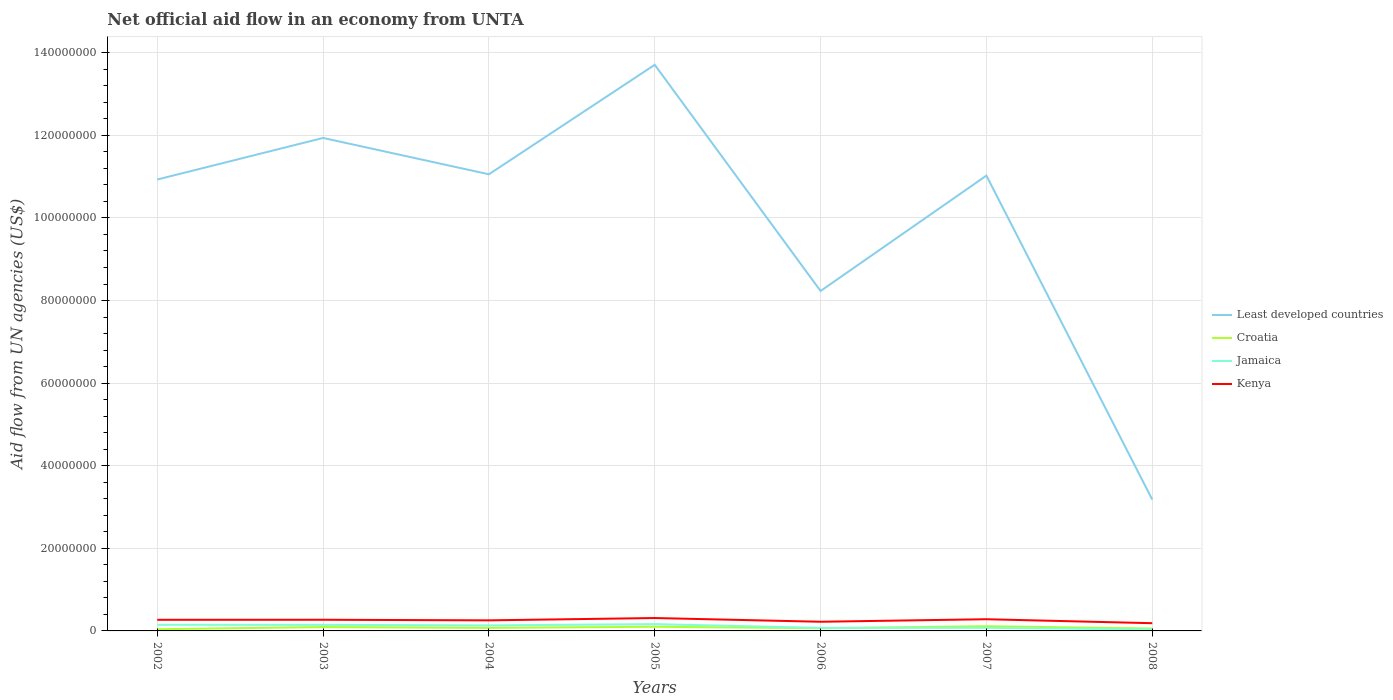How many different coloured lines are there?
Offer a very short reply. 4. Is the number of lines equal to the number of legend labels?
Your answer should be compact. Yes. Across all years, what is the maximum net official aid flow in Least developed countries?
Your response must be concise. 3.18e+07. What is the total net official aid flow in Croatia in the graph?
Ensure brevity in your answer.  4.40e+05. What is the difference between the highest and the second highest net official aid flow in Croatia?
Ensure brevity in your answer.  7.30e+05. Is the net official aid flow in Croatia strictly greater than the net official aid flow in Jamaica over the years?
Give a very brief answer. No. How many lines are there?
Provide a succinct answer. 4. Does the graph contain any zero values?
Offer a very short reply. No. Where does the legend appear in the graph?
Provide a short and direct response. Center right. How many legend labels are there?
Provide a succinct answer. 4. How are the legend labels stacked?
Your response must be concise. Vertical. What is the title of the graph?
Give a very brief answer. Net official aid flow in an economy from UNTA. Does "Tunisia" appear as one of the legend labels in the graph?
Give a very brief answer. No. What is the label or title of the X-axis?
Provide a succinct answer. Years. What is the label or title of the Y-axis?
Offer a very short reply. Aid flow from UN agencies (US$). What is the Aid flow from UN agencies (US$) of Least developed countries in 2002?
Offer a terse response. 1.09e+08. What is the Aid flow from UN agencies (US$) of Croatia in 2002?
Offer a very short reply. 4.10e+05. What is the Aid flow from UN agencies (US$) in Jamaica in 2002?
Your answer should be compact. 1.48e+06. What is the Aid flow from UN agencies (US$) of Kenya in 2002?
Offer a terse response. 2.69e+06. What is the Aid flow from UN agencies (US$) of Least developed countries in 2003?
Give a very brief answer. 1.19e+08. What is the Aid flow from UN agencies (US$) of Croatia in 2003?
Give a very brief answer. 9.30e+05. What is the Aid flow from UN agencies (US$) in Jamaica in 2003?
Provide a succinct answer. 1.47e+06. What is the Aid flow from UN agencies (US$) in Kenya in 2003?
Ensure brevity in your answer.  2.70e+06. What is the Aid flow from UN agencies (US$) of Least developed countries in 2004?
Your response must be concise. 1.11e+08. What is the Aid flow from UN agencies (US$) in Croatia in 2004?
Make the answer very short. 7.30e+05. What is the Aid flow from UN agencies (US$) in Jamaica in 2004?
Your answer should be compact. 1.34e+06. What is the Aid flow from UN agencies (US$) in Kenya in 2004?
Provide a short and direct response. 2.56e+06. What is the Aid flow from UN agencies (US$) in Least developed countries in 2005?
Provide a succinct answer. 1.37e+08. What is the Aid flow from UN agencies (US$) in Croatia in 2005?
Offer a very short reply. 1.01e+06. What is the Aid flow from UN agencies (US$) in Jamaica in 2005?
Provide a short and direct response. 1.65e+06. What is the Aid flow from UN agencies (US$) in Kenya in 2005?
Provide a short and direct response. 3.12e+06. What is the Aid flow from UN agencies (US$) of Least developed countries in 2006?
Provide a short and direct response. 8.23e+07. What is the Aid flow from UN agencies (US$) in Croatia in 2006?
Give a very brief answer. 6.50e+05. What is the Aid flow from UN agencies (US$) in Jamaica in 2006?
Offer a very short reply. 7.30e+05. What is the Aid flow from UN agencies (US$) in Kenya in 2006?
Offer a terse response. 2.22e+06. What is the Aid flow from UN agencies (US$) of Least developed countries in 2007?
Provide a short and direct response. 1.10e+08. What is the Aid flow from UN agencies (US$) of Croatia in 2007?
Offer a very short reply. 1.14e+06. What is the Aid flow from UN agencies (US$) of Jamaica in 2007?
Your answer should be compact. 7.40e+05. What is the Aid flow from UN agencies (US$) of Kenya in 2007?
Ensure brevity in your answer.  2.83e+06. What is the Aid flow from UN agencies (US$) of Least developed countries in 2008?
Your answer should be compact. 3.18e+07. What is the Aid flow from UN agencies (US$) in Croatia in 2008?
Make the answer very short. 5.70e+05. What is the Aid flow from UN agencies (US$) in Kenya in 2008?
Your answer should be very brief. 1.87e+06. Across all years, what is the maximum Aid flow from UN agencies (US$) of Least developed countries?
Provide a succinct answer. 1.37e+08. Across all years, what is the maximum Aid flow from UN agencies (US$) in Croatia?
Provide a succinct answer. 1.14e+06. Across all years, what is the maximum Aid flow from UN agencies (US$) of Jamaica?
Give a very brief answer. 1.65e+06. Across all years, what is the maximum Aid flow from UN agencies (US$) in Kenya?
Keep it short and to the point. 3.12e+06. Across all years, what is the minimum Aid flow from UN agencies (US$) in Least developed countries?
Give a very brief answer. 3.18e+07. Across all years, what is the minimum Aid flow from UN agencies (US$) in Jamaica?
Give a very brief answer. 3.40e+05. Across all years, what is the minimum Aid flow from UN agencies (US$) in Kenya?
Your response must be concise. 1.87e+06. What is the total Aid flow from UN agencies (US$) of Least developed countries in the graph?
Offer a very short reply. 7.01e+08. What is the total Aid flow from UN agencies (US$) of Croatia in the graph?
Ensure brevity in your answer.  5.44e+06. What is the total Aid flow from UN agencies (US$) of Jamaica in the graph?
Make the answer very short. 7.75e+06. What is the total Aid flow from UN agencies (US$) of Kenya in the graph?
Ensure brevity in your answer.  1.80e+07. What is the difference between the Aid flow from UN agencies (US$) of Least developed countries in 2002 and that in 2003?
Offer a terse response. -1.01e+07. What is the difference between the Aid flow from UN agencies (US$) of Croatia in 2002 and that in 2003?
Ensure brevity in your answer.  -5.20e+05. What is the difference between the Aid flow from UN agencies (US$) of Least developed countries in 2002 and that in 2004?
Keep it short and to the point. -1.27e+06. What is the difference between the Aid flow from UN agencies (US$) of Croatia in 2002 and that in 2004?
Provide a succinct answer. -3.20e+05. What is the difference between the Aid flow from UN agencies (US$) of Least developed countries in 2002 and that in 2005?
Provide a succinct answer. -2.78e+07. What is the difference between the Aid flow from UN agencies (US$) of Croatia in 2002 and that in 2005?
Provide a succinct answer. -6.00e+05. What is the difference between the Aid flow from UN agencies (US$) in Jamaica in 2002 and that in 2005?
Keep it short and to the point. -1.70e+05. What is the difference between the Aid flow from UN agencies (US$) in Kenya in 2002 and that in 2005?
Provide a short and direct response. -4.30e+05. What is the difference between the Aid flow from UN agencies (US$) in Least developed countries in 2002 and that in 2006?
Make the answer very short. 2.70e+07. What is the difference between the Aid flow from UN agencies (US$) in Jamaica in 2002 and that in 2006?
Ensure brevity in your answer.  7.50e+05. What is the difference between the Aid flow from UN agencies (US$) of Least developed countries in 2002 and that in 2007?
Your answer should be very brief. -9.50e+05. What is the difference between the Aid flow from UN agencies (US$) of Croatia in 2002 and that in 2007?
Make the answer very short. -7.30e+05. What is the difference between the Aid flow from UN agencies (US$) in Jamaica in 2002 and that in 2007?
Keep it short and to the point. 7.40e+05. What is the difference between the Aid flow from UN agencies (US$) in Least developed countries in 2002 and that in 2008?
Your answer should be compact. 7.75e+07. What is the difference between the Aid flow from UN agencies (US$) of Jamaica in 2002 and that in 2008?
Your response must be concise. 1.14e+06. What is the difference between the Aid flow from UN agencies (US$) of Kenya in 2002 and that in 2008?
Make the answer very short. 8.20e+05. What is the difference between the Aid flow from UN agencies (US$) in Least developed countries in 2003 and that in 2004?
Provide a short and direct response. 8.80e+06. What is the difference between the Aid flow from UN agencies (US$) of Croatia in 2003 and that in 2004?
Offer a terse response. 2.00e+05. What is the difference between the Aid flow from UN agencies (US$) in Kenya in 2003 and that in 2004?
Your answer should be very brief. 1.40e+05. What is the difference between the Aid flow from UN agencies (US$) of Least developed countries in 2003 and that in 2005?
Keep it short and to the point. -1.77e+07. What is the difference between the Aid flow from UN agencies (US$) of Kenya in 2003 and that in 2005?
Offer a very short reply. -4.20e+05. What is the difference between the Aid flow from UN agencies (US$) of Least developed countries in 2003 and that in 2006?
Ensure brevity in your answer.  3.71e+07. What is the difference between the Aid flow from UN agencies (US$) of Croatia in 2003 and that in 2006?
Make the answer very short. 2.80e+05. What is the difference between the Aid flow from UN agencies (US$) of Jamaica in 2003 and that in 2006?
Provide a short and direct response. 7.40e+05. What is the difference between the Aid flow from UN agencies (US$) in Kenya in 2003 and that in 2006?
Your answer should be compact. 4.80e+05. What is the difference between the Aid flow from UN agencies (US$) of Least developed countries in 2003 and that in 2007?
Offer a terse response. 9.12e+06. What is the difference between the Aid flow from UN agencies (US$) in Jamaica in 2003 and that in 2007?
Offer a very short reply. 7.30e+05. What is the difference between the Aid flow from UN agencies (US$) in Least developed countries in 2003 and that in 2008?
Your answer should be very brief. 8.76e+07. What is the difference between the Aid flow from UN agencies (US$) in Jamaica in 2003 and that in 2008?
Your answer should be compact. 1.13e+06. What is the difference between the Aid flow from UN agencies (US$) of Kenya in 2003 and that in 2008?
Keep it short and to the point. 8.30e+05. What is the difference between the Aid flow from UN agencies (US$) in Least developed countries in 2004 and that in 2005?
Your answer should be very brief. -2.65e+07. What is the difference between the Aid flow from UN agencies (US$) in Croatia in 2004 and that in 2005?
Provide a succinct answer. -2.80e+05. What is the difference between the Aid flow from UN agencies (US$) of Jamaica in 2004 and that in 2005?
Ensure brevity in your answer.  -3.10e+05. What is the difference between the Aid flow from UN agencies (US$) of Kenya in 2004 and that in 2005?
Provide a short and direct response. -5.60e+05. What is the difference between the Aid flow from UN agencies (US$) in Least developed countries in 2004 and that in 2006?
Keep it short and to the point. 2.83e+07. What is the difference between the Aid flow from UN agencies (US$) of Kenya in 2004 and that in 2006?
Offer a terse response. 3.40e+05. What is the difference between the Aid flow from UN agencies (US$) of Least developed countries in 2004 and that in 2007?
Your response must be concise. 3.20e+05. What is the difference between the Aid flow from UN agencies (US$) of Croatia in 2004 and that in 2007?
Your response must be concise. -4.10e+05. What is the difference between the Aid flow from UN agencies (US$) of Jamaica in 2004 and that in 2007?
Provide a short and direct response. 6.00e+05. What is the difference between the Aid flow from UN agencies (US$) of Least developed countries in 2004 and that in 2008?
Give a very brief answer. 7.88e+07. What is the difference between the Aid flow from UN agencies (US$) of Jamaica in 2004 and that in 2008?
Offer a very short reply. 1.00e+06. What is the difference between the Aid flow from UN agencies (US$) in Kenya in 2004 and that in 2008?
Provide a short and direct response. 6.90e+05. What is the difference between the Aid flow from UN agencies (US$) of Least developed countries in 2005 and that in 2006?
Keep it short and to the point. 5.48e+07. What is the difference between the Aid flow from UN agencies (US$) of Croatia in 2005 and that in 2006?
Provide a succinct answer. 3.60e+05. What is the difference between the Aid flow from UN agencies (US$) of Jamaica in 2005 and that in 2006?
Your response must be concise. 9.20e+05. What is the difference between the Aid flow from UN agencies (US$) of Kenya in 2005 and that in 2006?
Give a very brief answer. 9.00e+05. What is the difference between the Aid flow from UN agencies (US$) of Least developed countries in 2005 and that in 2007?
Offer a terse response. 2.68e+07. What is the difference between the Aid flow from UN agencies (US$) of Jamaica in 2005 and that in 2007?
Offer a very short reply. 9.10e+05. What is the difference between the Aid flow from UN agencies (US$) of Kenya in 2005 and that in 2007?
Offer a very short reply. 2.90e+05. What is the difference between the Aid flow from UN agencies (US$) of Least developed countries in 2005 and that in 2008?
Offer a very short reply. 1.05e+08. What is the difference between the Aid flow from UN agencies (US$) in Croatia in 2005 and that in 2008?
Keep it short and to the point. 4.40e+05. What is the difference between the Aid flow from UN agencies (US$) in Jamaica in 2005 and that in 2008?
Offer a very short reply. 1.31e+06. What is the difference between the Aid flow from UN agencies (US$) in Kenya in 2005 and that in 2008?
Keep it short and to the point. 1.25e+06. What is the difference between the Aid flow from UN agencies (US$) in Least developed countries in 2006 and that in 2007?
Ensure brevity in your answer.  -2.79e+07. What is the difference between the Aid flow from UN agencies (US$) in Croatia in 2006 and that in 2007?
Provide a succinct answer. -4.90e+05. What is the difference between the Aid flow from UN agencies (US$) in Jamaica in 2006 and that in 2007?
Your response must be concise. -10000. What is the difference between the Aid flow from UN agencies (US$) of Kenya in 2006 and that in 2007?
Your answer should be compact. -6.10e+05. What is the difference between the Aid flow from UN agencies (US$) in Least developed countries in 2006 and that in 2008?
Offer a very short reply. 5.05e+07. What is the difference between the Aid flow from UN agencies (US$) of Jamaica in 2006 and that in 2008?
Make the answer very short. 3.90e+05. What is the difference between the Aid flow from UN agencies (US$) of Least developed countries in 2007 and that in 2008?
Keep it short and to the point. 7.84e+07. What is the difference between the Aid flow from UN agencies (US$) of Croatia in 2007 and that in 2008?
Your response must be concise. 5.70e+05. What is the difference between the Aid flow from UN agencies (US$) in Jamaica in 2007 and that in 2008?
Give a very brief answer. 4.00e+05. What is the difference between the Aid flow from UN agencies (US$) of Kenya in 2007 and that in 2008?
Give a very brief answer. 9.60e+05. What is the difference between the Aid flow from UN agencies (US$) in Least developed countries in 2002 and the Aid flow from UN agencies (US$) in Croatia in 2003?
Keep it short and to the point. 1.08e+08. What is the difference between the Aid flow from UN agencies (US$) of Least developed countries in 2002 and the Aid flow from UN agencies (US$) of Jamaica in 2003?
Offer a terse response. 1.08e+08. What is the difference between the Aid flow from UN agencies (US$) in Least developed countries in 2002 and the Aid flow from UN agencies (US$) in Kenya in 2003?
Provide a short and direct response. 1.07e+08. What is the difference between the Aid flow from UN agencies (US$) of Croatia in 2002 and the Aid flow from UN agencies (US$) of Jamaica in 2003?
Keep it short and to the point. -1.06e+06. What is the difference between the Aid flow from UN agencies (US$) of Croatia in 2002 and the Aid flow from UN agencies (US$) of Kenya in 2003?
Your response must be concise. -2.29e+06. What is the difference between the Aid flow from UN agencies (US$) in Jamaica in 2002 and the Aid flow from UN agencies (US$) in Kenya in 2003?
Give a very brief answer. -1.22e+06. What is the difference between the Aid flow from UN agencies (US$) in Least developed countries in 2002 and the Aid flow from UN agencies (US$) in Croatia in 2004?
Make the answer very short. 1.09e+08. What is the difference between the Aid flow from UN agencies (US$) in Least developed countries in 2002 and the Aid flow from UN agencies (US$) in Jamaica in 2004?
Provide a succinct answer. 1.08e+08. What is the difference between the Aid flow from UN agencies (US$) of Least developed countries in 2002 and the Aid flow from UN agencies (US$) of Kenya in 2004?
Offer a very short reply. 1.07e+08. What is the difference between the Aid flow from UN agencies (US$) of Croatia in 2002 and the Aid flow from UN agencies (US$) of Jamaica in 2004?
Your response must be concise. -9.30e+05. What is the difference between the Aid flow from UN agencies (US$) of Croatia in 2002 and the Aid flow from UN agencies (US$) of Kenya in 2004?
Give a very brief answer. -2.15e+06. What is the difference between the Aid flow from UN agencies (US$) of Jamaica in 2002 and the Aid flow from UN agencies (US$) of Kenya in 2004?
Your answer should be very brief. -1.08e+06. What is the difference between the Aid flow from UN agencies (US$) of Least developed countries in 2002 and the Aid flow from UN agencies (US$) of Croatia in 2005?
Offer a terse response. 1.08e+08. What is the difference between the Aid flow from UN agencies (US$) of Least developed countries in 2002 and the Aid flow from UN agencies (US$) of Jamaica in 2005?
Offer a very short reply. 1.08e+08. What is the difference between the Aid flow from UN agencies (US$) in Least developed countries in 2002 and the Aid flow from UN agencies (US$) in Kenya in 2005?
Offer a very short reply. 1.06e+08. What is the difference between the Aid flow from UN agencies (US$) of Croatia in 2002 and the Aid flow from UN agencies (US$) of Jamaica in 2005?
Offer a terse response. -1.24e+06. What is the difference between the Aid flow from UN agencies (US$) in Croatia in 2002 and the Aid flow from UN agencies (US$) in Kenya in 2005?
Provide a succinct answer. -2.71e+06. What is the difference between the Aid flow from UN agencies (US$) in Jamaica in 2002 and the Aid flow from UN agencies (US$) in Kenya in 2005?
Offer a terse response. -1.64e+06. What is the difference between the Aid flow from UN agencies (US$) in Least developed countries in 2002 and the Aid flow from UN agencies (US$) in Croatia in 2006?
Ensure brevity in your answer.  1.09e+08. What is the difference between the Aid flow from UN agencies (US$) of Least developed countries in 2002 and the Aid flow from UN agencies (US$) of Jamaica in 2006?
Give a very brief answer. 1.09e+08. What is the difference between the Aid flow from UN agencies (US$) in Least developed countries in 2002 and the Aid flow from UN agencies (US$) in Kenya in 2006?
Your answer should be very brief. 1.07e+08. What is the difference between the Aid flow from UN agencies (US$) in Croatia in 2002 and the Aid flow from UN agencies (US$) in Jamaica in 2006?
Keep it short and to the point. -3.20e+05. What is the difference between the Aid flow from UN agencies (US$) in Croatia in 2002 and the Aid flow from UN agencies (US$) in Kenya in 2006?
Keep it short and to the point. -1.81e+06. What is the difference between the Aid flow from UN agencies (US$) of Jamaica in 2002 and the Aid flow from UN agencies (US$) of Kenya in 2006?
Your response must be concise. -7.40e+05. What is the difference between the Aid flow from UN agencies (US$) of Least developed countries in 2002 and the Aid flow from UN agencies (US$) of Croatia in 2007?
Keep it short and to the point. 1.08e+08. What is the difference between the Aid flow from UN agencies (US$) in Least developed countries in 2002 and the Aid flow from UN agencies (US$) in Jamaica in 2007?
Your response must be concise. 1.09e+08. What is the difference between the Aid flow from UN agencies (US$) in Least developed countries in 2002 and the Aid flow from UN agencies (US$) in Kenya in 2007?
Ensure brevity in your answer.  1.06e+08. What is the difference between the Aid flow from UN agencies (US$) of Croatia in 2002 and the Aid flow from UN agencies (US$) of Jamaica in 2007?
Ensure brevity in your answer.  -3.30e+05. What is the difference between the Aid flow from UN agencies (US$) in Croatia in 2002 and the Aid flow from UN agencies (US$) in Kenya in 2007?
Provide a short and direct response. -2.42e+06. What is the difference between the Aid flow from UN agencies (US$) in Jamaica in 2002 and the Aid flow from UN agencies (US$) in Kenya in 2007?
Keep it short and to the point. -1.35e+06. What is the difference between the Aid flow from UN agencies (US$) in Least developed countries in 2002 and the Aid flow from UN agencies (US$) in Croatia in 2008?
Provide a succinct answer. 1.09e+08. What is the difference between the Aid flow from UN agencies (US$) of Least developed countries in 2002 and the Aid flow from UN agencies (US$) of Jamaica in 2008?
Provide a short and direct response. 1.09e+08. What is the difference between the Aid flow from UN agencies (US$) in Least developed countries in 2002 and the Aid flow from UN agencies (US$) in Kenya in 2008?
Provide a short and direct response. 1.07e+08. What is the difference between the Aid flow from UN agencies (US$) in Croatia in 2002 and the Aid flow from UN agencies (US$) in Jamaica in 2008?
Keep it short and to the point. 7.00e+04. What is the difference between the Aid flow from UN agencies (US$) of Croatia in 2002 and the Aid flow from UN agencies (US$) of Kenya in 2008?
Ensure brevity in your answer.  -1.46e+06. What is the difference between the Aid flow from UN agencies (US$) in Jamaica in 2002 and the Aid flow from UN agencies (US$) in Kenya in 2008?
Ensure brevity in your answer.  -3.90e+05. What is the difference between the Aid flow from UN agencies (US$) of Least developed countries in 2003 and the Aid flow from UN agencies (US$) of Croatia in 2004?
Your answer should be compact. 1.19e+08. What is the difference between the Aid flow from UN agencies (US$) of Least developed countries in 2003 and the Aid flow from UN agencies (US$) of Jamaica in 2004?
Your answer should be compact. 1.18e+08. What is the difference between the Aid flow from UN agencies (US$) of Least developed countries in 2003 and the Aid flow from UN agencies (US$) of Kenya in 2004?
Offer a terse response. 1.17e+08. What is the difference between the Aid flow from UN agencies (US$) in Croatia in 2003 and the Aid flow from UN agencies (US$) in Jamaica in 2004?
Offer a very short reply. -4.10e+05. What is the difference between the Aid flow from UN agencies (US$) of Croatia in 2003 and the Aid flow from UN agencies (US$) of Kenya in 2004?
Provide a succinct answer. -1.63e+06. What is the difference between the Aid flow from UN agencies (US$) in Jamaica in 2003 and the Aid flow from UN agencies (US$) in Kenya in 2004?
Keep it short and to the point. -1.09e+06. What is the difference between the Aid flow from UN agencies (US$) of Least developed countries in 2003 and the Aid flow from UN agencies (US$) of Croatia in 2005?
Your answer should be very brief. 1.18e+08. What is the difference between the Aid flow from UN agencies (US$) of Least developed countries in 2003 and the Aid flow from UN agencies (US$) of Jamaica in 2005?
Give a very brief answer. 1.18e+08. What is the difference between the Aid flow from UN agencies (US$) of Least developed countries in 2003 and the Aid flow from UN agencies (US$) of Kenya in 2005?
Give a very brief answer. 1.16e+08. What is the difference between the Aid flow from UN agencies (US$) in Croatia in 2003 and the Aid flow from UN agencies (US$) in Jamaica in 2005?
Your answer should be very brief. -7.20e+05. What is the difference between the Aid flow from UN agencies (US$) in Croatia in 2003 and the Aid flow from UN agencies (US$) in Kenya in 2005?
Make the answer very short. -2.19e+06. What is the difference between the Aid flow from UN agencies (US$) in Jamaica in 2003 and the Aid flow from UN agencies (US$) in Kenya in 2005?
Offer a terse response. -1.65e+06. What is the difference between the Aid flow from UN agencies (US$) in Least developed countries in 2003 and the Aid flow from UN agencies (US$) in Croatia in 2006?
Your response must be concise. 1.19e+08. What is the difference between the Aid flow from UN agencies (US$) in Least developed countries in 2003 and the Aid flow from UN agencies (US$) in Jamaica in 2006?
Offer a terse response. 1.19e+08. What is the difference between the Aid flow from UN agencies (US$) of Least developed countries in 2003 and the Aid flow from UN agencies (US$) of Kenya in 2006?
Your response must be concise. 1.17e+08. What is the difference between the Aid flow from UN agencies (US$) in Croatia in 2003 and the Aid flow from UN agencies (US$) in Kenya in 2006?
Your response must be concise. -1.29e+06. What is the difference between the Aid flow from UN agencies (US$) of Jamaica in 2003 and the Aid flow from UN agencies (US$) of Kenya in 2006?
Ensure brevity in your answer.  -7.50e+05. What is the difference between the Aid flow from UN agencies (US$) of Least developed countries in 2003 and the Aid flow from UN agencies (US$) of Croatia in 2007?
Ensure brevity in your answer.  1.18e+08. What is the difference between the Aid flow from UN agencies (US$) in Least developed countries in 2003 and the Aid flow from UN agencies (US$) in Jamaica in 2007?
Provide a succinct answer. 1.19e+08. What is the difference between the Aid flow from UN agencies (US$) of Least developed countries in 2003 and the Aid flow from UN agencies (US$) of Kenya in 2007?
Make the answer very short. 1.17e+08. What is the difference between the Aid flow from UN agencies (US$) in Croatia in 2003 and the Aid flow from UN agencies (US$) in Kenya in 2007?
Make the answer very short. -1.90e+06. What is the difference between the Aid flow from UN agencies (US$) of Jamaica in 2003 and the Aid flow from UN agencies (US$) of Kenya in 2007?
Keep it short and to the point. -1.36e+06. What is the difference between the Aid flow from UN agencies (US$) in Least developed countries in 2003 and the Aid flow from UN agencies (US$) in Croatia in 2008?
Keep it short and to the point. 1.19e+08. What is the difference between the Aid flow from UN agencies (US$) in Least developed countries in 2003 and the Aid flow from UN agencies (US$) in Jamaica in 2008?
Offer a very short reply. 1.19e+08. What is the difference between the Aid flow from UN agencies (US$) in Least developed countries in 2003 and the Aid flow from UN agencies (US$) in Kenya in 2008?
Make the answer very short. 1.18e+08. What is the difference between the Aid flow from UN agencies (US$) in Croatia in 2003 and the Aid flow from UN agencies (US$) in Jamaica in 2008?
Your response must be concise. 5.90e+05. What is the difference between the Aid flow from UN agencies (US$) of Croatia in 2003 and the Aid flow from UN agencies (US$) of Kenya in 2008?
Your answer should be very brief. -9.40e+05. What is the difference between the Aid flow from UN agencies (US$) in Jamaica in 2003 and the Aid flow from UN agencies (US$) in Kenya in 2008?
Make the answer very short. -4.00e+05. What is the difference between the Aid flow from UN agencies (US$) in Least developed countries in 2004 and the Aid flow from UN agencies (US$) in Croatia in 2005?
Provide a short and direct response. 1.10e+08. What is the difference between the Aid flow from UN agencies (US$) in Least developed countries in 2004 and the Aid flow from UN agencies (US$) in Jamaica in 2005?
Provide a succinct answer. 1.09e+08. What is the difference between the Aid flow from UN agencies (US$) of Least developed countries in 2004 and the Aid flow from UN agencies (US$) of Kenya in 2005?
Offer a very short reply. 1.07e+08. What is the difference between the Aid flow from UN agencies (US$) of Croatia in 2004 and the Aid flow from UN agencies (US$) of Jamaica in 2005?
Provide a succinct answer. -9.20e+05. What is the difference between the Aid flow from UN agencies (US$) in Croatia in 2004 and the Aid flow from UN agencies (US$) in Kenya in 2005?
Provide a succinct answer. -2.39e+06. What is the difference between the Aid flow from UN agencies (US$) of Jamaica in 2004 and the Aid flow from UN agencies (US$) of Kenya in 2005?
Give a very brief answer. -1.78e+06. What is the difference between the Aid flow from UN agencies (US$) in Least developed countries in 2004 and the Aid flow from UN agencies (US$) in Croatia in 2006?
Offer a terse response. 1.10e+08. What is the difference between the Aid flow from UN agencies (US$) in Least developed countries in 2004 and the Aid flow from UN agencies (US$) in Jamaica in 2006?
Your response must be concise. 1.10e+08. What is the difference between the Aid flow from UN agencies (US$) in Least developed countries in 2004 and the Aid flow from UN agencies (US$) in Kenya in 2006?
Your answer should be compact. 1.08e+08. What is the difference between the Aid flow from UN agencies (US$) of Croatia in 2004 and the Aid flow from UN agencies (US$) of Kenya in 2006?
Your answer should be very brief. -1.49e+06. What is the difference between the Aid flow from UN agencies (US$) of Jamaica in 2004 and the Aid flow from UN agencies (US$) of Kenya in 2006?
Make the answer very short. -8.80e+05. What is the difference between the Aid flow from UN agencies (US$) of Least developed countries in 2004 and the Aid flow from UN agencies (US$) of Croatia in 2007?
Ensure brevity in your answer.  1.09e+08. What is the difference between the Aid flow from UN agencies (US$) of Least developed countries in 2004 and the Aid flow from UN agencies (US$) of Jamaica in 2007?
Offer a terse response. 1.10e+08. What is the difference between the Aid flow from UN agencies (US$) of Least developed countries in 2004 and the Aid flow from UN agencies (US$) of Kenya in 2007?
Give a very brief answer. 1.08e+08. What is the difference between the Aid flow from UN agencies (US$) in Croatia in 2004 and the Aid flow from UN agencies (US$) in Jamaica in 2007?
Provide a short and direct response. -10000. What is the difference between the Aid flow from UN agencies (US$) in Croatia in 2004 and the Aid flow from UN agencies (US$) in Kenya in 2007?
Your answer should be compact. -2.10e+06. What is the difference between the Aid flow from UN agencies (US$) of Jamaica in 2004 and the Aid flow from UN agencies (US$) of Kenya in 2007?
Ensure brevity in your answer.  -1.49e+06. What is the difference between the Aid flow from UN agencies (US$) in Least developed countries in 2004 and the Aid flow from UN agencies (US$) in Croatia in 2008?
Ensure brevity in your answer.  1.10e+08. What is the difference between the Aid flow from UN agencies (US$) in Least developed countries in 2004 and the Aid flow from UN agencies (US$) in Jamaica in 2008?
Your response must be concise. 1.10e+08. What is the difference between the Aid flow from UN agencies (US$) in Least developed countries in 2004 and the Aid flow from UN agencies (US$) in Kenya in 2008?
Your answer should be very brief. 1.09e+08. What is the difference between the Aid flow from UN agencies (US$) of Croatia in 2004 and the Aid flow from UN agencies (US$) of Jamaica in 2008?
Your answer should be compact. 3.90e+05. What is the difference between the Aid flow from UN agencies (US$) of Croatia in 2004 and the Aid flow from UN agencies (US$) of Kenya in 2008?
Keep it short and to the point. -1.14e+06. What is the difference between the Aid flow from UN agencies (US$) in Jamaica in 2004 and the Aid flow from UN agencies (US$) in Kenya in 2008?
Provide a short and direct response. -5.30e+05. What is the difference between the Aid flow from UN agencies (US$) in Least developed countries in 2005 and the Aid flow from UN agencies (US$) in Croatia in 2006?
Make the answer very short. 1.36e+08. What is the difference between the Aid flow from UN agencies (US$) in Least developed countries in 2005 and the Aid flow from UN agencies (US$) in Jamaica in 2006?
Provide a succinct answer. 1.36e+08. What is the difference between the Aid flow from UN agencies (US$) in Least developed countries in 2005 and the Aid flow from UN agencies (US$) in Kenya in 2006?
Your response must be concise. 1.35e+08. What is the difference between the Aid flow from UN agencies (US$) in Croatia in 2005 and the Aid flow from UN agencies (US$) in Kenya in 2006?
Your answer should be compact. -1.21e+06. What is the difference between the Aid flow from UN agencies (US$) of Jamaica in 2005 and the Aid flow from UN agencies (US$) of Kenya in 2006?
Offer a terse response. -5.70e+05. What is the difference between the Aid flow from UN agencies (US$) in Least developed countries in 2005 and the Aid flow from UN agencies (US$) in Croatia in 2007?
Offer a terse response. 1.36e+08. What is the difference between the Aid flow from UN agencies (US$) in Least developed countries in 2005 and the Aid flow from UN agencies (US$) in Jamaica in 2007?
Ensure brevity in your answer.  1.36e+08. What is the difference between the Aid flow from UN agencies (US$) in Least developed countries in 2005 and the Aid flow from UN agencies (US$) in Kenya in 2007?
Ensure brevity in your answer.  1.34e+08. What is the difference between the Aid flow from UN agencies (US$) in Croatia in 2005 and the Aid flow from UN agencies (US$) in Kenya in 2007?
Give a very brief answer. -1.82e+06. What is the difference between the Aid flow from UN agencies (US$) of Jamaica in 2005 and the Aid flow from UN agencies (US$) of Kenya in 2007?
Offer a terse response. -1.18e+06. What is the difference between the Aid flow from UN agencies (US$) in Least developed countries in 2005 and the Aid flow from UN agencies (US$) in Croatia in 2008?
Your response must be concise. 1.37e+08. What is the difference between the Aid flow from UN agencies (US$) in Least developed countries in 2005 and the Aid flow from UN agencies (US$) in Jamaica in 2008?
Your answer should be compact. 1.37e+08. What is the difference between the Aid flow from UN agencies (US$) of Least developed countries in 2005 and the Aid flow from UN agencies (US$) of Kenya in 2008?
Give a very brief answer. 1.35e+08. What is the difference between the Aid flow from UN agencies (US$) in Croatia in 2005 and the Aid flow from UN agencies (US$) in Jamaica in 2008?
Provide a succinct answer. 6.70e+05. What is the difference between the Aid flow from UN agencies (US$) in Croatia in 2005 and the Aid flow from UN agencies (US$) in Kenya in 2008?
Offer a very short reply. -8.60e+05. What is the difference between the Aid flow from UN agencies (US$) of Least developed countries in 2006 and the Aid flow from UN agencies (US$) of Croatia in 2007?
Your answer should be very brief. 8.12e+07. What is the difference between the Aid flow from UN agencies (US$) of Least developed countries in 2006 and the Aid flow from UN agencies (US$) of Jamaica in 2007?
Your answer should be compact. 8.16e+07. What is the difference between the Aid flow from UN agencies (US$) in Least developed countries in 2006 and the Aid flow from UN agencies (US$) in Kenya in 2007?
Offer a very short reply. 7.95e+07. What is the difference between the Aid flow from UN agencies (US$) of Croatia in 2006 and the Aid flow from UN agencies (US$) of Jamaica in 2007?
Provide a succinct answer. -9.00e+04. What is the difference between the Aid flow from UN agencies (US$) in Croatia in 2006 and the Aid flow from UN agencies (US$) in Kenya in 2007?
Your answer should be compact. -2.18e+06. What is the difference between the Aid flow from UN agencies (US$) of Jamaica in 2006 and the Aid flow from UN agencies (US$) of Kenya in 2007?
Give a very brief answer. -2.10e+06. What is the difference between the Aid flow from UN agencies (US$) in Least developed countries in 2006 and the Aid flow from UN agencies (US$) in Croatia in 2008?
Give a very brief answer. 8.17e+07. What is the difference between the Aid flow from UN agencies (US$) of Least developed countries in 2006 and the Aid flow from UN agencies (US$) of Jamaica in 2008?
Offer a very short reply. 8.20e+07. What is the difference between the Aid flow from UN agencies (US$) of Least developed countries in 2006 and the Aid flow from UN agencies (US$) of Kenya in 2008?
Your answer should be very brief. 8.04e+07. What is the difference between the Aid flow from UN agencies (US$) in Croatia in 2006 and the Aid flow from UN agencies (US$) in Kenya in 2008?
Offer a very short reply. -1.22e+06. What is the difference between the Aid flow from UN agencies (US$) in Jamaica in 2006 and the Aid flow from UN agencies (US$) in Kenya in 2008?
Provide a succinct answer. -1.14e+06. What is the difference between the Aid flow from UN agencies (US$) of Least developed countries in 2007 and the Aid flow from UN agencies (US$) of Croatia in 2008?
Offer a very short reply. 1.10e+08. What is the difference between the Aid flow from UN agencies (US$) of Least developed countries in 2007 and the Aid flow from UN agencies (US$) of Jamaica in 2008?
Keep it short and to the point. 1.10e+08. What is the difference between the Aid flow from UN agencies (US$) in Least developed countries in 2007 and the Aid flow from UN agencies (US$) in Kenya in 2008?
Offer a terse response. 1.08e+08. What is the difference between the Aid flow from UN agencies (US$) of Croatia in 2007 and the Aid flow from UN agencies (US$) of Kenya in 2008?
Offer a very short reply. -7.30e+05. What is the difference between the Aid flow from UN agencies (US$) in Jamaica in 2007 and the Aid flow from UN agencies (US$) in Kenya in 2008?
Your answer should be very brief. -1.13e+06. What is the average Aid flow from UN agencies (US$) of Least developed countries per year?
Make the answer very short. 1.00e+08. What is the average Aid flow from UN agencies (US$) of Croatia per year?
Provide a succinct answer. 7.77e+05. What is the average Aid flow from UN agencies (US$) in Jamaica per year?
Your response must be concise. 1.11e+06. What is the average Aid flow from UN agencies (US$) in Kenya per year?
Offer a very short reply. 2.57e+06. In the year 2002, what is the difference between the Aid flow from UN agencies (US$) of Least developed countries and Aid flow from UN agencies (US$) of Croatia?
Ensure brevity in your answer.  1.09e+08. In the year 2002, what is the difference between the Aid flow from UN agencies (US$) of Least developed countries and Aid flow from UN agencies (US$) of Jamaica?
Offer a very short reply. 1.08e+08. In the year 2002, what is the difference between the Aid flow from UN agencies (US$) in Least developed countries and Aid flow from UN agencies (US$) in Kenya?
Give a very brief answer. 1.07e+08. In the year 2002, what is the difference between the Aid flow from UN agencies (US$) in Croatia and Aid flow from UN agencies (US$) in Jamaica?
Make the answer very short. -1.07e+06. In the year 2002, what is the difference between the Aid flow from UN agencies (US$) of Croatia and Aid flow from UN agencies (US$) of Kenya?
Give a very brief answer. -2.28e+06. In the year 2002, what is the difference between the Aid flow from UN agencies (US$) of Jamaica and Aid flow from UN agencies (US$) of Kenya?
Make the answer very short. -1.21e+06. In the year 2003, what is the difference between the Aid flow from UN agencies (US$) of Least developed countries and Aid flow from UN agencies (US$) of Croatia?
Offer a very short reply. 1.18e+08. In the year 2003, what is the difference between the Aid flow from UN agencies (US$) in Least developed countries and Aid flow from UN agencies (US$) in Jamaica?
Offer a terse response. 1.18e+08. In the year 2003, what is the difference between the Aid flow from UN agencies (US$) in Least developed countries and Aid flow from UN agencies (US$) in Kenya?
Provide a short and direct response. 1.17e+08. In the year 2003, what is the difference between the Aid flow from UN agencies (US$) in Croatia and Aid flow from UN agencies (US$) in Jamaica?
Ensure brevity in your answer.  -5.40e+05. In the year 2003, what is the difference between the Aid flow from UN agencies (US$) of Croatia and Aid flow from UN agencies (US$) of Kenya?
Your answer should be very brief. -1.77e+06. In the year 2003, what is the difference between the Aid flow from UN agencies (US$) of Jamaica and Aid flow from UN agencies (US$) of Kenya?
Provide a short and direct response. -1.23e+06. In the year 2004, what is the difference between the Aid flow from UN agencies (US$) in Least developed countries and Aid flow from UN agencies (US$) in Croatia?
Make the answer very short. 1.10e+08. In the year 2004, what is the difference between the Aid flow from UN agencies (US$) of Least developed countries and Aid flow from UN agencies (US$) of Jamaica?
Your answer should be very brief. 1.09e+08. In the year 2004, what is the difference between the Aid flow from UN agencies (US$) of Least developed countries and Aid flow from UN agencies (US$) of Kenya?
Provide a succinct answer. 1.08e+08. In the year 2004, what is the difference between the Aid flow from UN agencies (US$) in Croatia and Aid flow from UN agencies (US$) in Jamaica?
Make the answer very short. -6.10e+05. In the year 2004, what is the difference between the Aid flow from UN agencies (US$) of Croatia and Aid flow from UN agencies (US$) of Kenya?
Your answer should be very brief. -1.83e+06. In the year 2004, what is the difference between the Aid flow from UN agencies (US$) in Jamaica and Aid flow from UN agencies (US$) in Kenya?
Ensure brevity in your answer.  -1.22e+06. In the year 2005, what is the difference between the Aid flow from UN agencies (US$) of Least developed countries and Aid flow from UN agencies (US$) of Croatia?
Offer a terse response. 1.36e+08. In the year 2005, what is the difference between the Aid flow from UN agencies (US$) in Least developed countries and Aid flow from UN agencies (US$) in Jamaica?
Give a very brief answer. 1.35e+08. In the year 2005, what is the difference between the Aid flow from UN agencies (US$) in Least developed countries and Aid flow from UN agencies (US$) in Kenya?
Provide a succinct answer. 1.34e+08. In the year 2005, what is the difference between the Aid flow from UN agencies (US$) of Croatia and Aid flow from UN agencies (US$) of Jamaica?
Your response must be concise. -6.40e+05. In the year 2005, what is the difference between the Aid flow from UN agencies (US$) of Croatia and Aid flow from UN agencies (US$) of Kenya?
Your response must be concise. -2.11e+06. In the year 2005, what is the difference between the Aid flow from UN agencies (US$) in Jamaica and Aid flow from UN agencies (US$) in Kenya?
Offer a terse response. -1.47e+06. In the year 2006, what is the difference between the Aid flow from UN agencies (US$) in Least developed countries and Aid flow from UN agencies (US$) in Croatia?
Your answer should be compact. 8.17e+07. In the year 2006, what is the difference between the Aid flow from UN agencies (US$) in Least developed countries and Aid flow from UN agencies (US$) in Jamaica?
Provide a short and direct response. 8.16e+07. In the year 2006, what is the difference between the Aid flow from UN agencies (US$) in Least developed countries and Aid flow from UN agencies (US$) in Kenya?
Provide a short and direct response. 8.01e+07. In the year 2006, what is the difference between the Aid flow from UN agencies (US$) in Croatia and Aid flow from UN agencies (US$) in Jamaica?
Keep it short and to the point. -8.00e+04. In the year 2006, what is the difference between the Aid flow from UN agencies (US$) of Croatia and Aid flow from UN agencies (US$) of Kenya?
Offer a very short reply. -1.57e+06. In the year 2006, what is the difference between the Aid flow from UN agencies (US$) of Jamaica and Aid flow from UN agencies (US$) of Kenya?
Ensure brevity in your answer.  -1.49e+06. In the year 2007, what is the difference between the Aid flow from UN agencies (US$) of Least developed countries and Aid flow from UN agencies (US$) of Croatia?
Make the answer very short. 1.09e+08. In the year 2007, what is the difference between the Aid flow from UN agencies (US$) in Least developed countries and Aid flow from UN agencies (US$) in Jamaica?
Make the answer very short. 1.10e+08. In the year 2007, what is the difference between the Aid flow from UN agencies (US$) in Least developed countries and Aid flow from UN agencies (US$) in Kenya?
Offer a terse response. 1.07e+08. In the year 2007, what is the difference between the Aid flow from UN agencies (US$) of Croatia and Aid flow from UN agencies (US$) of Jamaica?
Give a very brief answer. 4.00e+05. In the year 2007, what is the difference between the Aid flow from UN agencies (US$) of Croatia and Aid flow from UN agencies (US$) of Kenya?
Make the answer very short. -1.69e+06. In the year 2007, what is the difference between the Aid flow from UN agencies (US$) of Jamaica and Aid flow from UN agencies (US$) of Kenya?
Your response must be concise. -2.09e+06. In the year 2008, what is the difference between the Aid flow from UN agencies (US$) in Least developed countries and Aid flow from UN agencies (US$) in Croatia?
Offer a terse response. 3.12e+07. In the year 2008, what is the difference between the Aid flow from UN agencies (US$) in Least developed countries and Aid flow from UN agencies (US$) in Jamaica?
Your answer should be very brief. 3.15e+07. In the year 2008, what is the difference between the Aid flow from UN agencies (US$) in Least developed countries and Aid flow from UN agencies (US$) in Kenya?
Offer a very short reply. 2.99e+07. In the year 2008, what is the difference between the Aid flow from UN agencies (US$) of Croatia and Aid flow from UN agencies (US$) of Jamaica?
Ensure brevity in your answer.  2.30e+05. In the year 2008, what is the difference between the Aid flow from UN agencies (US$) in Croatia and Aid flow from UN agencies (US$) in Kenya?
Your answer should be compact. -1.30e+06. In the year 2008, what is the difference between the Aid flow from UN agencies (US$) of Jamaica and Aid flow from UN agencies (US$) of Kenya?
Ensure brevity in your answer.  -1.53e+06. What is the ratio of the Aid flow from UN agencies (US$) of Least developed countries in 2002 to that in 2003?
Give a very brief answer. 0.92. What is the ratio of the Aid flow from UN agencies (US$) in Croatia in 2002 to that in 2003?
Your answer should be compact. 0.44. What is the ratio of the Aid flow from UN agencies (US$) in Jamaica in 2002 to that in 2003?
Keep it short and to the point. 1.01. What is the ratio of the Aid flow from UN agencies (US$) in Kenya in 2002 to that in 2003?
Offer a terse response. 1. What is the ratio of the Aid flow from UN agencies (US$) in Croatia in 2002 to that in 2004?
Your response must be concise. 0.56. What is the ratio of the Aid flow from UN agencies (US$) in Jamaica in 2002 to that in 2004?
Provide a succinct answer. 1.1. What is the ratio of the Aid flow from UN agencies (US$) of Kenya in 2002 to that in 2004?
Give a very brief answer. 1.05. What is the ratio of the Aid flow from UN agencies (US$) in Least developed countries in 2002 to that in 2005?
Offer a very short reply. 0.8. What is the ratio of the Aid flow from UN agencies (US$) in Croatia in 2002 to that in 2005?
Make the answer very short. 0.41. What is the ratio of the Aid flow from UN agencies (US$) in Jamaica in 2002 to that in 2005?
Keep it short and to the point. 0.9. What is the ratio of the Aid flow from UN agencies (US$) in Kenya in 2002 to that in 2005?
Give a very brief answer. 0.86. What is the ratio of the Aid flow from UN agencies (US$) in Least developed countries in 2002 to that in 2006?
Offer a terse response. 1.33. What is the ratio of the Aid flow from UN agencies (US$) of Croatia in 2002 to that in 2006?
Make the answer very short. 0.63. What is the ratio of the Aid flow from UN agencies (US$) in Jamaica in 2002 to that in 2006?
Keep it short and to the point. 2.03. What is the ratio of the Aid flow from UN agencies (US$) in Kenya in 2002 to that in 2006?
Provide a short and direct response. 1.21. What is the ratio of the Aid flow from UN agencies (US$) of Least developed countries in 2002 to that in 2007?
Your answer should be very brief. 0.99. What is the ratio of the Aid flow from UN agencies (US$) of Croatia in 2002 to that in 2007?
Provide a succinct answer. 0.36. What is the ratio of the Aid flow from UN agencies (US$) of Jamaica in 2002 to that in 2007?
Your answer should be compact. 2. What is the ratio of the Aid flow from UN agencies (US$) of Kenya in 2002 to that in 2007?
Your answer should be compact. 0.95. What is the ratio of the Aid flow from UN agencies (US$) of Least developed countries in 2002 to that in 2008?
Your response must be concise. 3.44. What is the ratio of the Aid flow from UN agencies (US$) of Croatia in 2002 to that in 2008?
Make the answer very short. 0.72. What is the ratio of the Aid flow from UN agencies (US$) of Jamaica in 2002 to that in 2008?
Keep it short and to the point. 4.35. What is the ratio of the Aid flow from UN agencies (US$) in Kenya in 2002 to that in 2008?
Your response must be concise. 1.44. What is the ratio of the Aid flow from UN agencies (US$) in Least developed countries in 2003 to that in 2004?
Your answer should be compact. 1.08. What is the ratio of the Aid flow from UN agencies (US$) in Croatia in 2003 to that in 2004?
Provide a short and direct response. 1.27. What is the ratio of the Aid flow from UN agencies (US$) in Jamaica in 2003 to that in 2004?
Provide a short and direct response. 1.1. What is the ratio of the Aid flow from UN agencies (US$) of Kenya in 2003 to that in 2004?
Ensure brevity in your answer.  1.05. What is the ratio of the Aid flow from UN agencies (US$) in Least developed countries in 2003 to that in 2005?
Provide a short and direct response. 0.87. What is the ratio of the Aid flow from UN agencies (US$) in Croatia in 2003 to that in 2005?
Offer a terse response. 0.92. What is the ratio of the Aid flow from UN agencies (US$) in Jamaica in 2003 to that in 2005?
Offer a terse response. 0.89. What is the ratio of the Aid flow from UN agencies (US$) of Kenya in 2003 to that in 2005?
Your answer should be compact. 0.87. What is the ratio of the Aid flow from UN agencies (US$) of Least developed countries in 2003 to that in 2006?
Provide a short and direct response. 1.45. What is the ratio of the Aid flow from UN agencies (US$) of Croatia in 2003 to that in 2006?
Offer a terse response. 1.43. What is the ratio of the Aid flow from UN agencies (US$) of Jamaica in 2003 to that in 2006?
Your answer should be compact. 2.01. What is the ratio of the Aid flow from UN agencies (US$) in Kenya in 2003 to that in 2006?
Give a very brief answer. 1.22. What is the ratio of the Aid flow from UN agencies (US$) in Least developed countries in 2003 to that in 2007?
Make the answer very short. 1.08. What is the ratio of the Aid flow from UN agencies (US$) in Croatia in 2003 to that in 2007?
Keep it short and to the point. 0.82. What is the ratio of the Aid flow from UN agencies (US$) in Jamaica in 2003 to that in 2007?
Ensure brevity in your answer.  1.99. What is the ratio of the Aid flow from UN agencies (US$) of Kenya in 2003 to that in 2007?
Make the answer very short. 0.95. What is the ratio of the Aid flow from UN agencies (US$) in Least developed countries in 2003 to that in 2008?
Provide a short and direct response. 3.75. What is the ratio of the Aid flow from UN agencies (US$) in Croatia in 2003 to that in 2008?
Keep it short and to the point. 1.63. What is the ratio of the Aid flow from UN agencies (US$) in Jamaica in 2003 to that in 2008?
Give a very brief answer. 4.32. What is the ratio of the Aid flow from UN agencies (US$) in Kenya in 2003 to that in 2008?
Offer a terse response. 1.44. What is the ratio of the Aid flow from UN agencies (US$) in Least developed countries in 2004 to that in 2005?
Keep it short and to the point. 0.81. What is the ratio of the Aid flow from UN agencies (US$) in Croatia in 2004 to that in 2005?
Offer a very short reply. 0.72. What is the ratio of the Aid flow from UN agencies (US$) of Jamaica in 2004 to that in 2005?
Your answer should be very brief. 0.81. What is the ratio of the Aid flow from UN agencies (US$) of Kenya in 2004 to that in 2005?
Your response must be concise. 0.82. What is the ratio of the Aid flow from UN agencies (US$) of Least developed countries in 2004 to that in 2006?
Provide a succinct answer. 1.34. What is the ratio of the Aid flow from UN agencies (US$) of Croatia in 2004 to that in 2006?
Provide a short and direct response. 1.12. What is the ratio of the Aid flow from UN agencies (US$) in Jamaica in 2004 to that in 2006?
Provide a succinct answer. 1.84. What is the ratio of the Aid flow from UN agencies (US$) of Kenya in 2004 to that in 2006?
Offer a very short reply. 1.15. What is the ratio of the Aid flow from UN agencies (US$) of Croatia in 2004 to that in 2007?
Provide a short and direct response. 0.64. What is the ratio of the Aid flow from UN agencies (US$) of Jamaica in 2004 to that in 2007?
Your answer should be compact. 1.81. What is the ratio of the Aid flow from UN agencies (US$) in Kenya in 2004 to that in 2007?
Provide a short and direct response. 0.9. What is the ratio of the Aid flow from UN agencies (US$) in Least developed countries in 2004 to that in 2008?
Offer a very short reply. 3.48. What is the ratio of the Aid flow from UN agencies (US$) of Croatia in 2004 to that in 2008?
Give a very brief answer. 1.28. What is the ratio of the Aid flow from UN agencies (US$) in Jamaica in 2004 to that in 2008?
Ensure brevity in your answer.  3.94. What is the ratio of the Aid flow from UN agencies (US$) in Kenya in 2004 to that in 2008?
Offer a very short reply. 1.37. What is the ratio of the Aid flow from UN agencies (US$) in Least developed countries in 2005 to that in 2006?
Offer a terse response. 1.67. What is the ratio of the Aid flow from UN agencies (US$) of Croatia in 2005 to that in 2006?
Provide a succinct answer. 1.55. What is the ratio of the Aid flow from UN agencies (US$) of Jamaica in 2005 to that in 2006?
Provide a succinct answer. 2.26. What is the ratio of the Aid flow from UN agencies (US$) of Kenya in 2005 to that in 2006?
Provide a succinct answer. 1.41. What is the ratio of the Aid flow from UN agencies (US$) in Least developed countries in 2005 to that in 2007?
Keep it short and to the point. 1.24. What is the ratio of the Aid flow from UN agencies (US$) of Croatia in 2005 to that in 2007?
Offer a very short reply. 0.89. What is the ratio of the Aid flow from UN agencies (US$) in Jamaica in 2005 to that in 2007?
Provide a short and direct response. 2.23. What is the ratio of the Aid flow from UN agencies (US$) in Kenya in 2005 to that in 2007?
Offer a terse response. 1.1. What is the ratio of the Aid flow from UN agencies (US$) in Least developed countries in 2005 to that in 2008?
Keep it short and to the point. 4.31. What is the ratio of the Aid flow from UN agencies (US$) in Croatia in 2005 to that in 2008?
Keep it short and to the point. 1.77. What is the ratio of the Aid flow from UN agencies (US$) in Jamaica in 2005 to that in 2008?
Offer a very short reply. 4.85. What is the ratio of the Aid flow from UN agencies (US$) in Kenya in 2005 to that in 2008?
Provide a short and direct response. 1.67. What is the ratio of the Aid flow from UN agencies (US$) in Least developed countries in 2006 to that in 2007?
Your answer should be very brief. 0.75. What is the ratio of the Aid flow from UN agencies (US$) of Croatia in 2006 to that in 2007?
Your response must be concise. 0.57. What is the ratio of the Aid flow from UN agencies (US$) of Jamaica in 2006 to that in 2007?
Ensure brevity in your answer.  0.99. What is the ratio of the Aid flow from UN agencies (US$) in Kenya in 2006 to that in 2007?
Make the answer very short. 0.78. What is the ratio of the Aid flow from UN agencies (US$) of Least developed countries in 2006 to that in 2008?
Ensure brevity in your answer.  2.59. What is the ratio of the Aid flow from UN agencies (US$) of Croatia in 2006 to that in 2008?
Keep it short and to the point. 1.14. What is the ratio of the Aid flow from UN agencies (US$) in Jamaica in 2006 to that in 2008?
Offer a terse response. 2.15. What is the ratio of the Aid flow from UN agencies (US$) in Kenya in 2006 to that in 2008?
Provide a succinct answer. 1.19. What is the ratio of the Aid flow from UN agencies (US$) of Least developed countries in 2007 to that in 2008?
Provide a short and direct response. 3.47. What is the ratio of the Aid flow from UN agencies (US$) of Jamaica in 2007 to that in 2008?
Ensure brevity in your answer.  2.18. What is the ratio of the Aid flow from UN agencies (US$) in Kenya in 2007 to that in 2008?
Offer a terse response. 1.51. What is the difference between the highest and the second highest Aid flow from UN agencies (US$) in Least developed countries?
Offer a very short reply. 1.77e+07. What is the difference between the highest and the second highest Aid flow from UN agencies (US$) in Croatia?
Offer a very short reply. 1.30e+05. What is the difference between the highest and the lowest Aid flow from UN agencies (US$) in Least developed countries?
Offer a very short reply. 1.05e+08. What is the difference between the highest and the lowest Aid flow from UN agencies (US$) in Croatia?
Offer a terse response. 7.30e+05. What is the difference between the highest and the lowest Aid flow from UN agencies (US$) of Jamaica?
Give a very brief answer. 1.31e+06. What is the difference between the highest and the lowest Aid flow from UN agencies (US$) in Kenya?
Make the answer very short. 1.25e+06. 